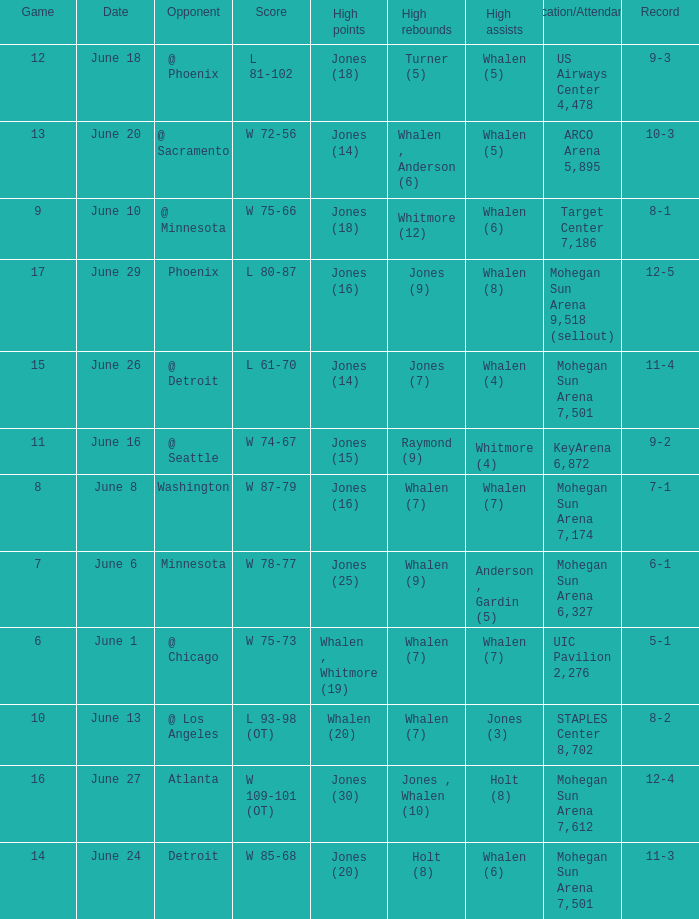What is the game on june 29? 17.0. 